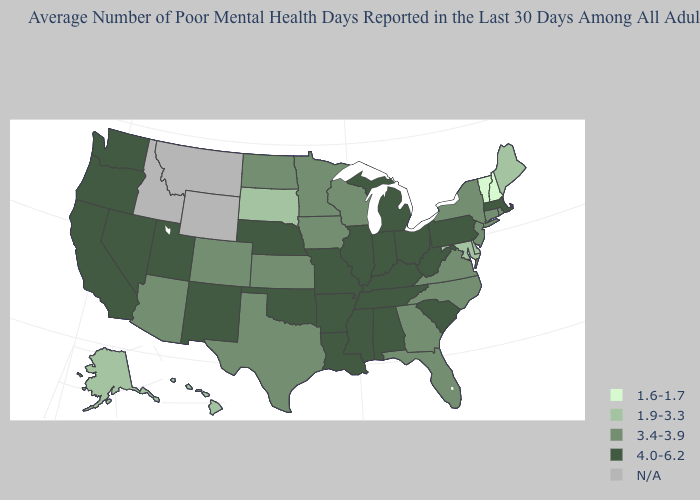Name the states that have a value in the range 1.9-3.3?
Short answer required. Alaska, Delaware, Hawaii, Maine, Maryland, South Dakota. Among the states that border Delaware , which have the lowest value?
Be succinct. Maryland. Name the states that have a value in the range 3.4-3.9?
Give a very brief answer. Arizona, Colorado, Connecticut, Florida, Georgia, Iowa, Kansas, Minnesota, New Jersey, New York, North Carolina, North Dakota, Rhode Island, Texas, Virginia, Wisconsin. Which states have the lowest value in the USA?
Short answer required. New Hampshire, Vermont. How many symbols are there in the legend?
Answer briefly. 5. Does Vermont have the lowest value in the USA?
Be succinct. Yes. What is the lowest value in the USA?
Short answer required. 1.6-1.7. Among the states that border Montana , does South Dakota have the highest value?
Concise answer only. No. Name the states that have a value in the range 1.6-1.7?
Write a very short answer. New Hampshire, Vermont. Is the legend a continuous bar?
Be succinct. No. Which states hav the highest value in the MidWest?
Write a very short answer. Illinois, Indiana, Michigan, Missouri, Nebraska, Ohio. What is the value of Arkansas?
Concise answer only. 4.0-6.2. Name the states that have a value in the range 4.0-6.2?
Be succinct. Alabama, Arkansas, California, Illinois, Indiana, Kentucky, Louisiana, Massachusetts, Michigan, Mississippi, Missouri, Nebraska, Nevada, New Mexico, Ohio, Oklahoma, Oregon, Pennsylvania, South Carolina, Tennessee, Utah, Washington, West Virginia. Which states have the lowest value in the South?
Short answer required. Delaware, Maryland. Name the states that have a value in the range 4.0-6.2?
Answer briefly. Alabama, Arkansas, California, Illinois, Indiana, Kentucky, Louisiana, Massachusetts, Michigan, Mississippi, Missouri, Nebraska, Nevada, New Mexico, Ohio, Oklahoma, Oregon, Pennsylvania, South Carolina, Tennessee, Utah, Washington, West Virginia. 